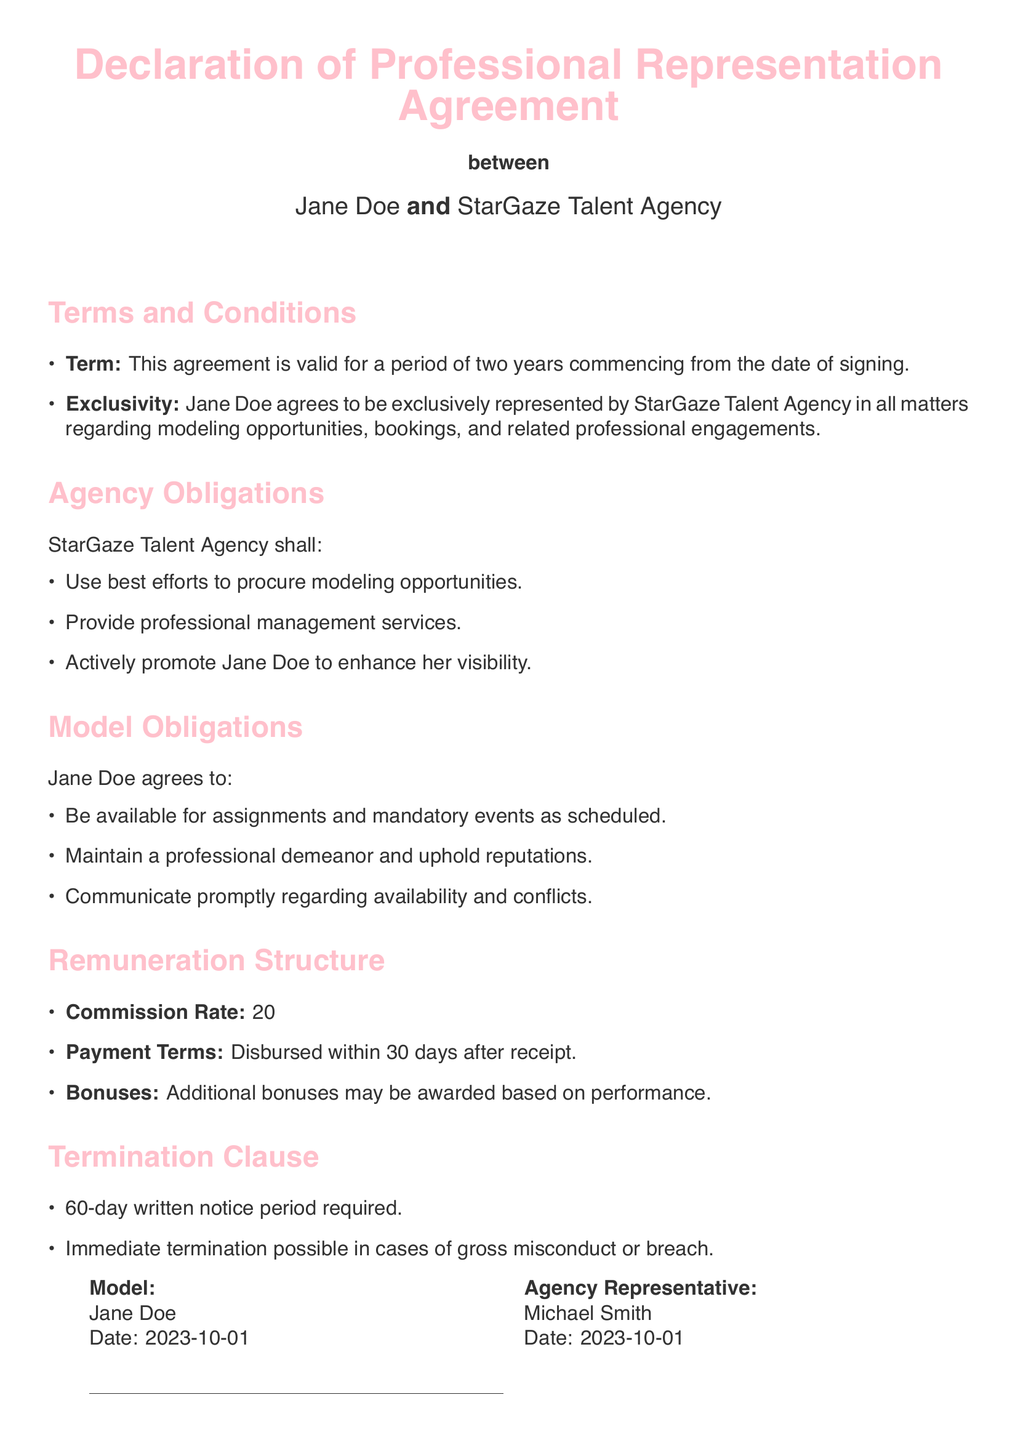What is the duration of the agreement? The term stated in the document specifies that the agreement is valid for a period of two years commencing from the date of signing.
Answer: two years Who is the agency representative? The document lists a specific individual representing the agency, which is named in the signature section.
Answer: Michael Smith What is the commission rate? The remuneration structure specifies the percentage that the agency will take from the model's gross earnings.
Answer: 20% What must Jane Doe maintain according to her obligations? The obligations section details the expectations on Jane Doe, specifically highlighting the need to maintain a certain demeanor.
Answer: professional demeanor What is the notice period required for termination? The termination clause indicates the amount of notice that must be given for terminating the agreement.
Answer: 60-day What type of opportunities is the agency obligated to procure? The agency's obligations detail the types of engagements they are responsible for securing on behalf of the model.
Answer: modeling opportunities In what circumstances can the agreement be terminated immediately? The termination clause outlines specific instances that would allow for immediate cancellation of the agreement.
Answer: gross misconduct What date was the agreement signed? The signing date is included in the footer of the document next to the respective names.
Answer: 2023-10-01 